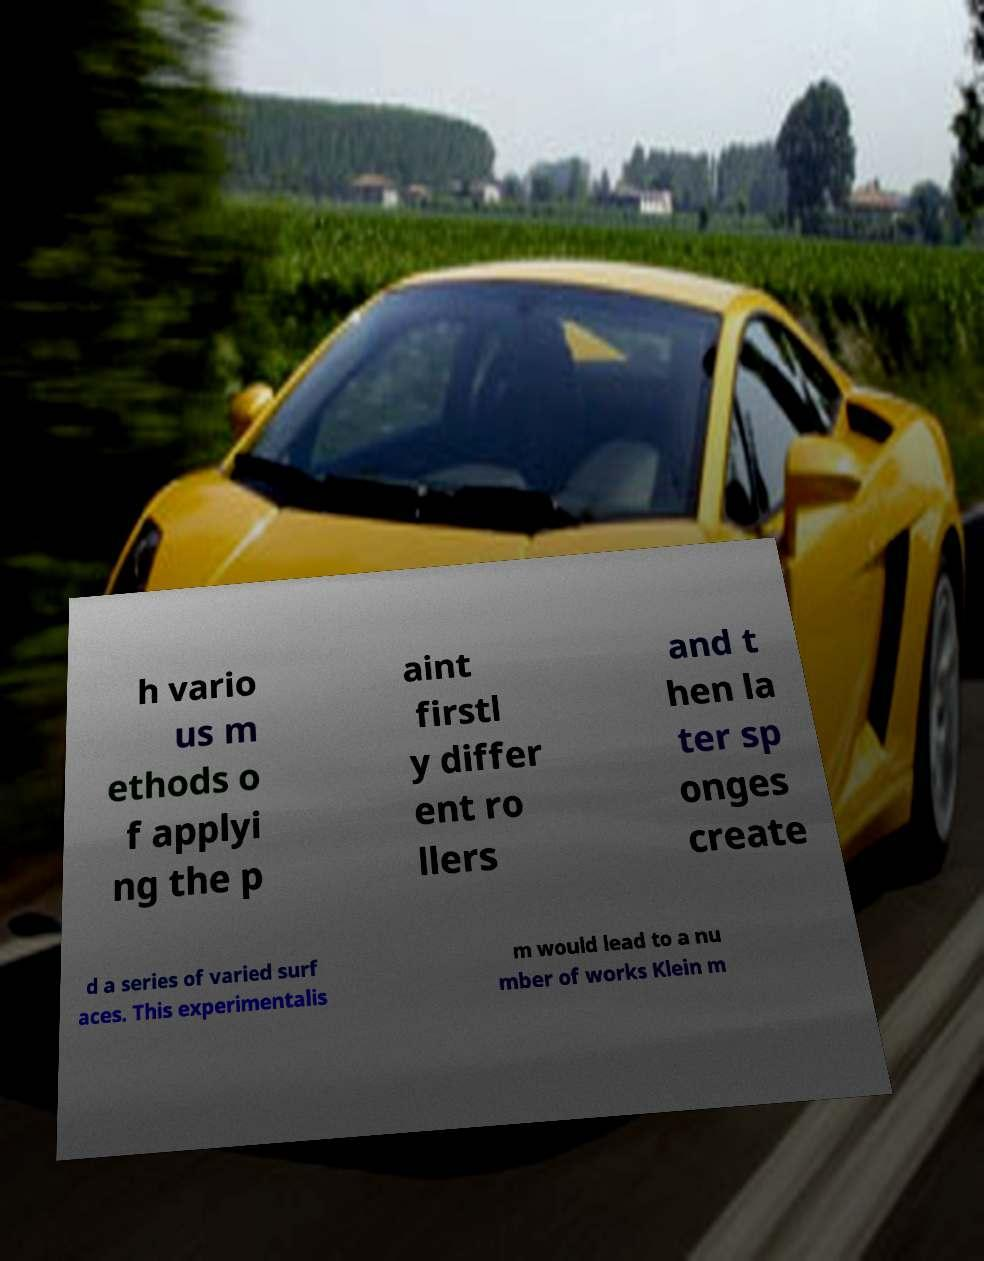Could you extract and type out the text from this image? h vario us m ethods o f applyi ng the p aint firstl y differ ent ro llers and t hen la ter sp onges create d a series of varied surf aces. This experimentalis m would lead to a nu mber of works Klein m 